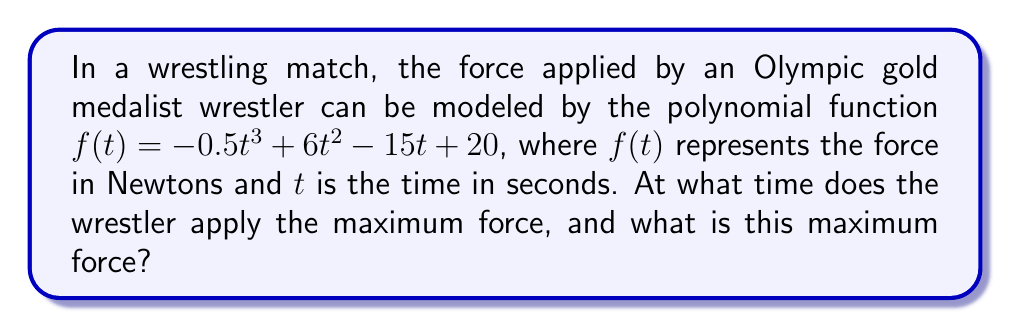Can you answer this question? To find the maximum force and the time at which it occurs, we need to follow these steps:

1) The maximum force will occur at a critical point of the function. To find critical points, we need to find where the derivative of the function is zero or undefined.

2) Let's find the derivative of $f(t)$:
   $f'(t) = -1.5t^2 + 12t - 15$

3) Now, let's set $f'(t) = 0$ and solve for $t$:
   $-1.5t^2 + 12t - 15 = 0$

4) This is a quadratic equation. We can solve it using the quadratic formula:
   $t = \frac{-b \pm \sqrt{b^2 - 4ac}}{2a}$

   Where $a = -1.5$, $b = 12$, and $c = -15$

5) Plugging in these values:
   $t = \frac{-12 \pm \sqrt{12^2 - 4(-1.5)(-15)}}{2(-1.5)}$
   $= \frac{-12 \pm \sqrt{144 - 90}}{-3}$
   $= \frac{-12 \pm \sqrt{54}}{-3}$
   $= \frac{-12 \pm 3\sqrt{6}}{-3}$

6) This gives us two solutions:
   $t_1 = \frac{-12 + 3\sqrt{6}}{-3} = 4 - \sqrt{6} \approx 1.55$ seconds
   $t_2 = \frac{-12 - 3\sqrt{6}}{-3} = 4 + \sqrt{6} \approx 6.45$ seconds

7) To determine which of these gives the maximum (rather than minimum) force, we can check the second derivative:
   $f''(t) = -3t + 12$

8) At $t = 4 - \sqrt{6}$, $f''(t) > 0$, indicating this is a local minimum.
   At $t = 4 + \sqrt{6}$, $f''(t) < 0$, indicating this is a local maximum.

9) Therefore, the maximum force occurs at $t = 4 + \sqrt{6} \approx 6.45$ seconds.

10) To find the maximum force, we plug this value of $t$ back into our original function:
    $f(4 + \sqrt{6}) = -0.5(4 + \sqrt{6})^3 + 6(4 + \sqrt{6})^2 - 15(4 + \sqrt{6}) + 20$

11) Simplifying this (which involves some complex algebra):
    $f(4 + \sqrt{6}) = 20 + 6\sqrt{6} \approx 34.7$ Newtons
Answer: The wrestler applies the maximum force at approximately 6.45 seconds, and this maximum force is approximately 34.7 Newtons. 